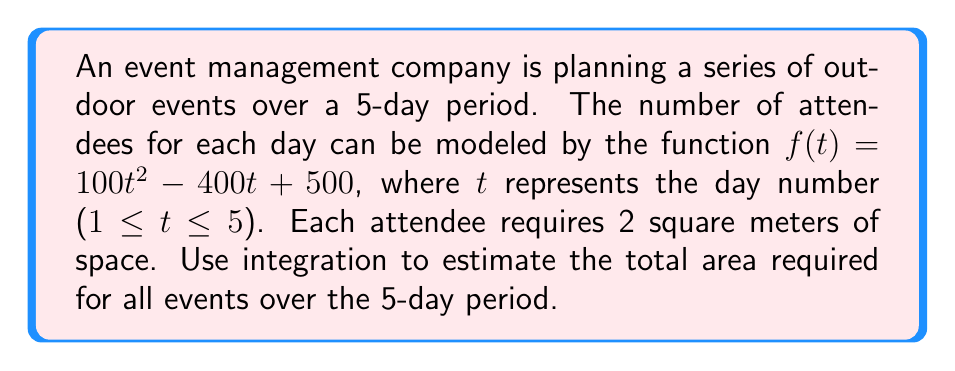Solve this math problem. To solve this problem, we need to follow these steps:

1) The function $f(t) = 100t^2 - 400t + 500$ represents the number of attendees on day $t$.

2) To find the total number of attendees over the 5-day period, we need to integrate this function from $t=1$ to $t=5$.

3) Each attendee requires 2 square meters, so we'll multiply our result by 2 at the end.

4) Let's set up the integral:

   $$\int_{1}^{5} (100t^2 - 400t + 500) dt$$

5) Integrate the function:

   $$\left[\frac{100t^3}{3} - 200t^2 + 500t\right]_{1}^{5}$$

6) Evaluate the integral:

   $$\left(\frac{100(5^3)}{3} - 200(5^2) + 500(5)\right) - \left(\frac{100(1^3)}{3} - 200(1^2) + 500(1)\right)$$

   $$= (4166.67 - 5000 + 2500) - (33.33 - 200 + 500)$$

   $$= 1666.67 - 333.33 = 1333.34$$

7) This result represents the total number of attendees over the 5-day period.

8) To get the total area required, multiply by 2 square meters per person:

   $$1333.34 \times 2 = 2666.68$$

Therefore, the estimated total area required for all events over the 5-day period is 2666.68 square meters.
Answer: 2666.68 square meters 